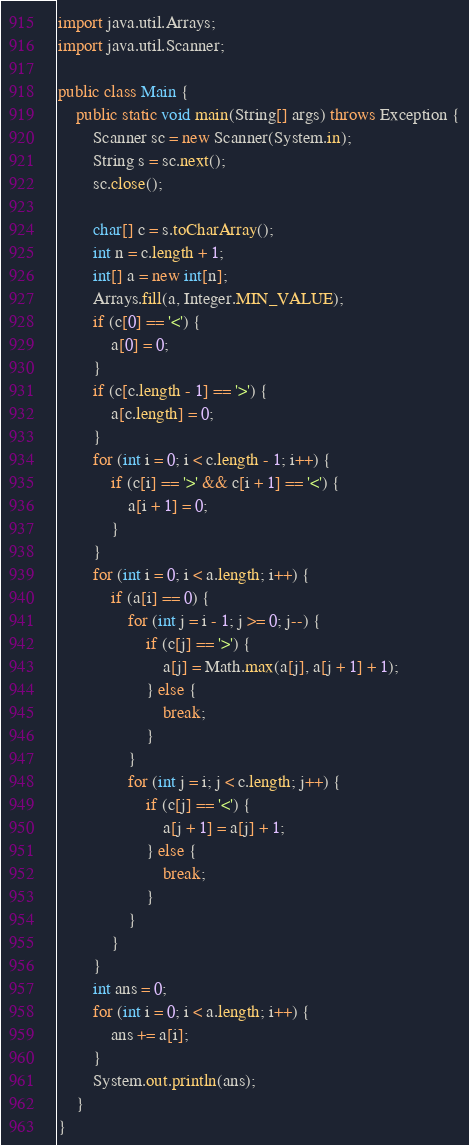<code> <loc_0><loc_0><loc_500><loc_500><_Java_>import java.util.Arrays;
import java.util.Scanner;

public class Main {
	public static void main(String[] args) throws Exception {
		Scanner sc = new Scanner(System.in);
		String s = sc.next();
		sc.close();

		char[] c = s.toCharArray();
		int n = c.length + 1;
		int[] a = new int[n];
		Arrays.fill(a, Integer.MIN_VALUE);
		if (c[0] == '<') {
			a[0] = 0;
		}
		if (c[c.length - 1] == '>') {
			a[c.length] = 0;
		}
		for (int i = 0; i < c.length - 1; i++) {
			if (c[i] == '>' && c[i + 1] == '<') {
				a[i + 1] = 0;
			}
		}
		for (int i = 0; i < a.length; i++) {
			if (a[i] == 0) {
				for (int j = i - 1; j >= 0; j--) {
					if (c[j] == '>') {
						a[j] = Math.max(a[j], a[j + 1] + 1);
					} else {
						break;
					}
				}
				for (int j = i; j < c.length; j++) {
					if (c[j] == '<') {
						a[j + 1] = a[j] + 1;
					} else {
						break;
					}
				}
			}
		}
		int ans = 0;
		for (int i = 0; i < a.length; i++) {
			ans += a[i];
		}
		System.out.println(ans);
	}
}
</code> 